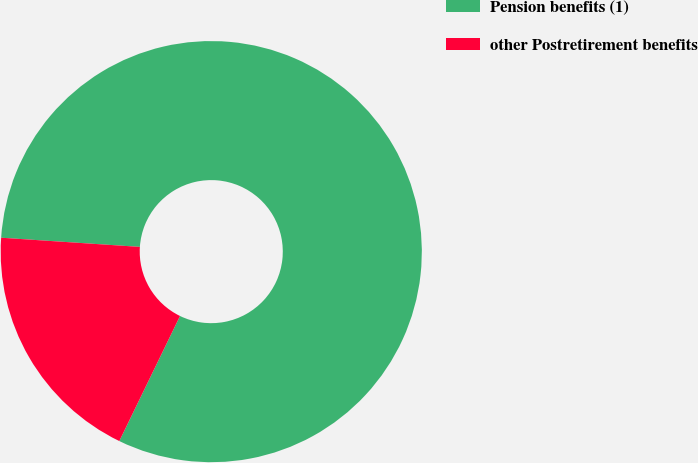Convert chart. <chart><loc_0><loc_0><loc_500><loc_500><pie_chart><fcel>Pension benefits (1)<fcel>other Postretirement benefits<nl><fcel>81.14%<fcel>18.86%<nl></chart> 